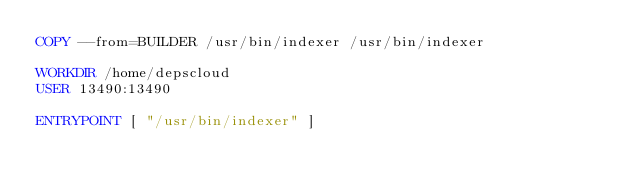<code> <loc_0><loc_0><loc_500><loc_500><_Dockerfile_>COPY --from=BUILDER /usr/bin/indexer /usr/bin/indexer

WORKDIR /home/depscloud
USER 13490:13490

ENTRYPOINT [ "/usr/bin/indexer" ]
</code> 